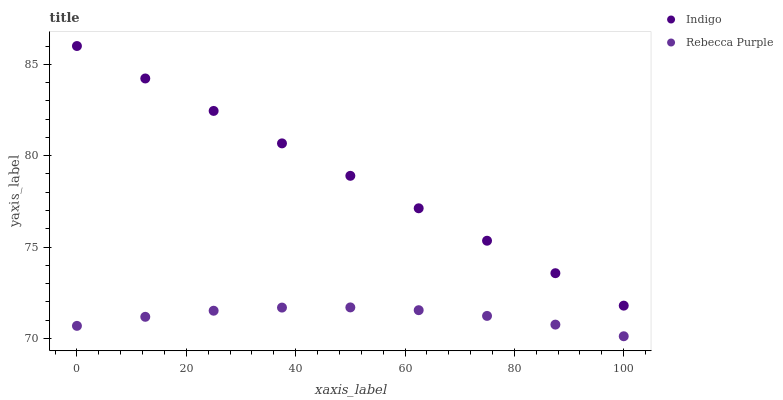Does Rebecca Purple have the minimum area under the curve?
Answer yes or no. Yes. Does Indigo have the maximum area under the curve?
Answer yes or no. Yes. Does Rebecca Purple have the maximum area under the curve?
Answer yes or no. No. Is Indigo the smoothest?
Answer yes or no. Yes. Is Rebecca Purple the roughest?
Answer yes or no. Yes. Is Rebecca Purple the smoothest?
Answer yes or no. No. Does Rebecca Purple have the lowest value?
Answer yes or no. Yes. Does Indigo have the highest value?
Answer yes or no. Yes. Does Rebecca Purple have the highest value?
Answer yes or no. No. Is Rebecca Purple less than Indigo?
Answer yes or no. Yes. Is Indigo greater than Rebecca Purple?
Answer yes or no. Yes. Does Rebecca Purple intersect Indigo?
Answer yes or no. No. 